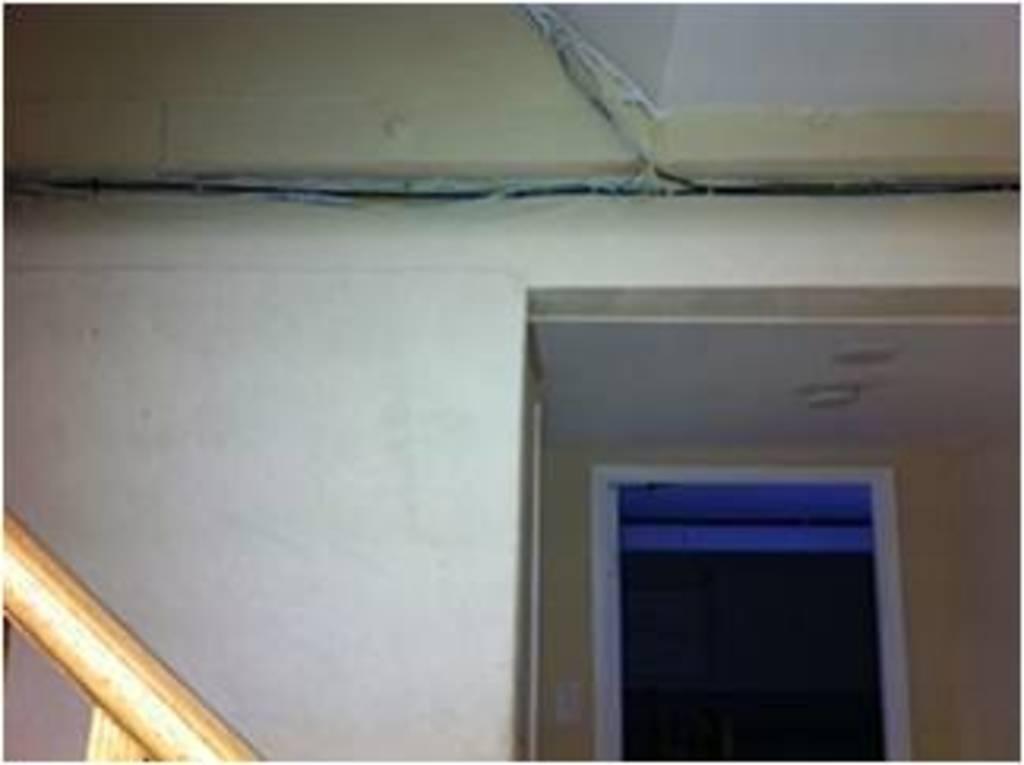Please provide a concise description of this image. In the image we can see there is a inner view of a building´s room. There is a wooden pole and there is a door. There is a roof and the wall is in white colour. 